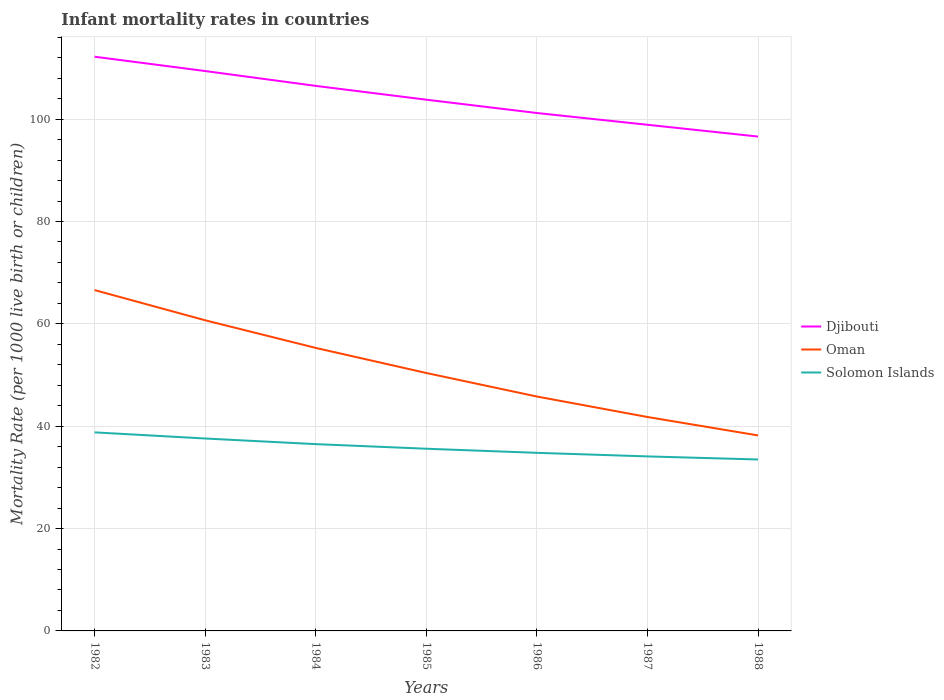How many different coloured lines are there?
Give a very brief answer. 3. Does the line corresponding to Solomon Islands intersect with the line corresponding to Djibouti?
Your response must be concise. No. Across all years, what is the maximum infant mortality rate in Djibouti?
Your answer should be very brief. 96.6. What is the total infant mortality rate in Oman in the graph?
Your response must be concise. 4.9. What is the difference between the highest and the second highest infant mortality rate in Djibouti?
Provide a short and direct response. 15.6. What is the difference between the highest and the lowest infant mortality rate in Solomon Islands?
Make the answer very short. 3. Is the infant mortality rate in Djibouti strictly greater than the infant mortality rate in Solomon Islands over the years?
Make the answer very short. No. How many years are there in the graph?
Make the answer very short. 7. What is the difference between two consecutive major ticks on the Y-axis?
Provide a succinct answer. 20. Does the graph contain grids?
Offer a terse response. Yes. How many legend labels are there?
Offer a very short reply. 3. How are the legend labels stacked?
Provide a short and direct response. Vertical. What is the title of the graph?
Provide a short and direct response. Infant mortality rates in countries. What is the label or title of the Y-axis?
Your answer should be very brief. Mortality Rate (per 1000 live birth or children). What is the Mortality Rate (per 1000 live birth or children) in Djibouti in 1982?
Make the answer very short. 112.2. What is the Mortality Rate (per 1000 live birth or children) in Oman in 1982?
Offer a terse response. 66.6. What is the Mortality Rate (per 1000 live birth or children) of Solomon Islands in 1982?
Give a very brief answer. 38.8. What is the Mortality Rate (per 1000 live birth or children) in Djibouti in 1983?
Offer a terse response. 109.4. What is the Mortality Rate (per 1000 live birth or children) in Oman in 1983?
Ensure brevity in your answer.  60.7. What is the Mortality Rate (per 1000 live birth or children) of Solomon Islands in 1983?
Make the answer very short. 37.6. What is the Mortality Rate (per 1000 live birth or children) of Djibouti in 1984?
Provide a short and direct response. 106.5. What is the Mortality Rate (per 1000 live birth or children) of Oman in 1984?
Offer a very short reply. 55.3. What is the Mortality Rate (per 1000 live birth or children) in Solomon Islands in 1984?
Offer a terse response. 36.5. What is the Mortality Rate (per 1000 live birth or children) of Djibouti in 1985?
Your answer should be very brief. 103.8. What is the Mortality Rate (per 1000 live birth or children) in Oman in 1985?
Provide a succinct answer. 50.4. What is the Mortality Rate (per 1000 live birth or children) in Solomon Islands in 1985?
Offer a very short reply. 35.6. What is the Mortality Rate (per 1000 live birth or children) of Djibouti in 1986?
Offer a very short reply. 101.2. What is the Mortality Rate (per 1000 live birth or children) in Oman in 1986?
Your answer should be compact. 45.8. What is the Mortality Rate (per 1000 live birth or children) of Solomon Islands in 1986?
Your answer should be compact. 34.8. What is the Mortality Rate (per 1000 live birth or children) of Djibouti in 1987?
Offer a terse response. 98.9. What is the Mortality Rate (per 1000 live birth or children) of Oman in 1987?
Keep it short and to the point. 41.8. What is the Mortality Rate (per 1000 live birth or children) in Solomon Islands in 1987?
Keep it short and to the point. 34.1. What is the Mortality Rate (per 1000 live birth or children) of Djibouti in 1988?
Your response must be concise. 96.6. What is the Mortality Rate (per 1000 live birth or children) in Oman in 1988?
Your response must be concise. 38.2. What is the Mortality Rate (per 1000 live birth or children) in Solomon Islands in 1988?
Give a very brief answer. 33.5. Across all years, what is the maximum Mortality Rate (per 1000 live birth or children) of Djibouti?
Make the answer very short. 112.2. Across all years, what is the maximum Mortality Rate (per 1000 live birth or children) of Oman?
Offer a terse response. 66.6. Across all years, what is the maximum Mortality Rate (per 1000 live birth or children) in Solomon Islands?
Offer a terse response. 38.8. Across all years, what is the minimum Mortality Rate (per 1000 live birth or children) in Djibouti?
Your answer should be compact. 96.6. Across all years, what is the minimum Mortality Rate (per 1000 live birth or children) of Oman?
Your answer should be compact. 38.2. Across all years, what is the minimum Mortality Rate (per 1000 live birth or children) of Solomon Islands?
Make the answer very short. 33.5. What is the total Mortality Rate (per 1000 live birth or children) in Djibouti in the graph?
Provide a short and direct response. 728.6. What is the total Mortality Rate (per 1000 live birth or children) of Oman in the graph?
Your answer should be very brief. 358.8. What is the total Mortality Rate (per 1000 live birth or children) of Solomon Islands in the graph?
Give a very brief answer. 250.9. What is the difference between the Mortality Rate (per 1000 live birth or children) in Djibouti in 1982 and that in 1983?
Your answer should be compact. 2.8. What is the difference between the Mortality Rate (per 1000 live birth or children) of Oman in 1982 and that in 1983?
Give a very brief answer. 5.9. What is the difference between the Mortality Rate (per 1000 live birth or children) in Djibouti in 1982 and that in 1985?
Your response must be concise. 8.4. What is the difference between the Mortality Rate (per 1000 live birth or children) of Oman in 1982 and that in 1985?
Offer a terse response. 16.2. What is the difference between the Mortality Rate (per 1000 live birth or children) of Oman in 1982 and that in 1986?
Make the answer very short. 20.8. What is the difference between the Mortality Rate (per 1000 live birth or children) in Solomon Islands in 1982 and that in 1986?
Offer a very short reply. 4. What is the difference between the Mortality Rate (per 1000 live birth or children) in Oman in 1982 and that in 1987?
Keep it short and to the point. 24.8. What is the difference between the Mortality Rate (per 1000 live birth or children) of Djibouti in 1982 and that in 1988?
Ensure brevity in your answer.  15.6. What is the difference between the Mortality Rate (per 1000 live birth or children) in Oman in 1982 and that in 1988?
Ensure brevity in your answer.  28.4. What is the difference between the Mortality Rate (per 1000 live birth or children) of Oman in 1983 and that in 1984?
Your answer should be very brief. 5.4. What is the difference between the Mortality Rate (per 1000 live birth or children) of Solomon Islands in 1983 and that in 1984?
Offer a very short reply. 1.1. What is the difference between the Mortality Rate (per 1000 live birth or children) of Solomon Islands in 1983 and that in 1985?
Make the answer very short. 2. What is the difference between the Mortality Rate (per 1000 live birth or children) of Oman in 1983 and that in 1987?
Provide a short and direct response. 18.9. What is the difference between the Mortality Rate (per 1000 live birth or children) of Djibouti in 1983 and that in 1988?
Ensure brevity in your answer.  12.8. What is the difference between the Mortality Rate (per 1000 live birth or children) of Solomon Islands in 1983 and that in 1988?
Your answer should be compact. 4.1. What is the difference between the Mortality Rate (per 1000 live birth or children) in Oman in 1984 and that in 1985?
Give a very brief answer. 4.9. What is the difference between the Mortality Rate (per 1000 live birth or children) of Solomon Islands in 1984 and that in 1985?
Keep it short and to the point. 0.9. What is the difference between the Mortality Rate (per 1000 live birth or children) of Oman in 1984 and that in 1987?
Offer a very short reply. 13.5. What is the difference between the Mortality Rate (per 1000 live birth or children) in Djibouti in 1985 and that in 1986?
Offer a very short reply. 2.6. What is the difference between the Mortality Rate (per 1000 live birth or children) of Oman in 1985 and that in 1986?
Your answer should be compact. 4.6. What is the difference between the Mortality Rate (per 1000 live birth or children) of Djibouti in 1985 and that in 1987?
Provide a succinct answer. 4.9. What is the difference between the Mortality Rate (per 1000 live birth or children) of Djibouti in 1985 and that in 1988?
Give a very brief answer. 7.2. What is the difference between the Mortality Rate (per 1000 live birth or children) of Oman in 1986 and that in 1987?
Provide a short and direct response. 4. What is the difference between the Mortality Rate (per 1000 live birth or children) in Djibouti in 1986 and that in 1988?
Your answer should be very brief. 4.6. What is the difference between the Mortality Rate (per 1000 live birth or children) in Djibouti in 1987 and that in 1988?
Keep it short and to the point. 2.3. What is the difference between the Mortality Rate (per 1000 live birth or children) in Oman in 1987 and that in 1988?
Make the answer very short. 3.6. What is the difference between the Mortality Rate (per 1000 live birth or children) of Solomon Islands in 1987 and that in 1988?
Your answer should be very brief. 0.6. What is the difference between the Mortality Rate (per 1000 live birth or children) in Djibouti in 1982 and the Mortality Rate (per 1000 live birth or children) in Oman in 1983?
Provide a short and direct response. 51.5. What is the difference between the Mortality Rate (per 1000 live birth or children) of Djibouti in 1982 and the Mortality Rate (per 1000 live birth or children) of Solomon Islands in 1983?
Your response must be concise. 74.6. What is the difference between the Mortality Rate (per 1000 live birth or children) of Djibouti in 1982 and the Mortality Rate (per 1000 live birth or children) of Oman in 1984?
Your answer should be compact. 56.9. What is the difference between the Mortality Rate (per 1000 live birth or children) in Djibouti in 1982 and the Mortality Rate (per 1000 live birth or children) in Solomon Islands in 1984?
Offer a terse response. 75.7. What is the difference between the Mortality Rate (per 1000 live birth or children) of Oman in 1982 and the Mortality Rate (per 1000 live birth or children) of Solomon Islands in 1984?
Ensure brevity in your answer.  30.1. What is the difference between the Mortality Rate (per 1000 live birth or children) of Djibouti in 1982 and the Mortality Rate (per 1000 live birth or children) of Oman in 1985?
Make the answer very short. 61.8. What is the difference between the Mortality Rate (per 1000 live birth or children) of Djibouti in 1982 and the Mortality Rate (per 1000 live birth or children) of Solomon Islands in 1985?
Provide a succinct answer. 76.6. What is the difference between the Mortality Rate (per 1000 live birth or children) of Djibouti in 1982 and the Mortality Rate (per 1000 live birth or children) of Oman in 1986?
Make the answer very short. 66.4. What is the difference between the Mortality Rate (per 1000 live birth or children) of Djibouti in 1982 and the Mortality Rate (per 1000 live birth or children) of Solomon Islands in 1986?
Keep it short and to the point. 77.4. What is the difference between the Mortality Rate (per 1000 live birth or children) in Oman in 1982 and the Mortality Rate (per 1000 live birth or children) in Solomon Islands in 1986?
Keep it short and to the point. 31.8. What is the difference between the Mortality Rate (per 1000 live birth or children) of Djibouti in 1982 and the Mortality Rate (per 1000 live birth or children) of Oman in 1987?
Provide a succinct answer. 70.4. What is the difference between the Mortality Rate (per 1000 live birth or children) in Djibouti in 1982 and the Mortality Rate (per 1000 live birth or children) in Solomon Islands in 1987?
Provide a succinct answer. 78.1. What is the difference between the Mortality Rate (per 1000 live birth or children) in Oman in 1982 and the Mortality Rate (per 1000 live birth or children) in Solomon Islands in 1987?
Ensure brevity in your answer.  32.5. What is the difference between the Mortality Rate (per 1000 live birth or children) of Djibouti in 1982 and the Mortality Rate (per 1000 live birth or children) of Solomon Islands in 1988?
Give a very brief answer. 78.7. What is the difference between the Mortality Rate (per 1000 live birth or children) in Oman in 1982 and the Mortality Rate (per 1000 live birth or children) in Solomon Islands in 1988?
Offer a terse response. 33.1. What is the difference between the Mortality Rate (per 1000 live birth or children) in Djibouti in 1983 and the Mortality Rate (per 1000 live birth or children) in Oman in 1984?
Your answer should be very brief. 54.1. What is the difference between the Mortality Rate (per 1000 live birth or children) of Djibouti in 1983 and the Mortality Rate (per 1000 live birth or children) of Solomon Islands in 1984?
Keep it short and to the point. 72.9. What is the difference between the Mortality Rate (per 1000 live birth or children) in Oman in 1983 and the Mortality Rate (per 1000 live birth or children) in Solomon Islands in 1984?
Make the answer very short. 24.2. What is the difference between the Mortality Rate (per 1000 live birth or children) of Djibouti in 1983 and the Mortality Rate (per 1000 live birth or children) of Solomon Islands in 1985?
Provide a short and direct response. 73.8. What is the difference between the Mortality Rate (per 1000 live birth or children) in Oman in 1983 and the Mortality Rate (per 1000 live birth or children) in Solomon Islands in 1985?
Provide a short and direct response. 25.1. What is the difference between the Mortality Rate (per 1000 live birth or children) of Djibouti in 1983 and the Mortality Rate (per 1000 live birth or children) of Oman in 1986?
Provide a short and direct response. 63.6. What is the difference between the Mortality Rate (per 1000 live birth or children) in Djibouti in 1983 and the Mortality Rate (per 1000 live birth or children) in Solomon Islands in 1986?
Your answer should be very brief. 74.6. What is the difference between the Mortality Rate (per 1000 live birth or children) of Oman in 1983 and the Mortality Rate (per 1000 live birth or children) of Solomon Islands in 1986?
Make the answer very short. 25.9. What is the difference between the Mortality Rate (per 1000 live birth or children) of Djibouti in 1983 and the Mortality Rate (per 1000 live birth or children) of Oman in 1987?
Your answer should be compact. 67.6. What is the difference between the Mortality Rate (per 1000 live birth or children) of Djibouti in 1983 and the Mortality Rate (per 1000 live birth or children) of Solomon Islands in 1987?
Provide a short and direct response. 75.3. What is the difference between the Mortality Rate (per 1000 live birth or children) of Oman in 1983 and the Mortality Rate (per 1000 live birth or children) of Solomon Islands in 1987?
Keep it short and to the point. 26.6. What is the difference between the Mortality Rate (per 1000 live birth or children) in Djibouti in 1983 and the Mortality Rate (per 1000 live birth or children) in Oman in 1988?
Your answer should be very brief. 71.2. What is the difference between the Mortality Rate (per 1000 live birth or children) of Djibouti in 1983 and the Mortality Rate (per 1000 live birth or children) of Solomon Islands in 1988?
Your answer should be compact. 75.9. What is the difference between the Mortality Rate (per 1000 live birth or children) in Oman in 1983 and the Mortality Rate (per 1000 live birth or children) in Solomon Islands in 1988?
Give a very brief answer. 27.2. What is the difference between the Mortality Rate (per 1000 live birth or children) of Djibouti in 1984 and the Mortality Rate (per 1000 live birth or children) of Oman in 1985?
Ensure brevity in your answer.  56.1. What is the difference between the Mortality Rate (per 1000 live birth or children) of Djibouti in 1984 and the Mortality Rate (per 1000 live birth or children) of Solomon Islands in 1985?
Ensure brevity in your answer.  70.9. What is the difference between the Mortality Rate (per 1000 live birth or children) of Oman in 1984 and the Mortality Rate (per 1000 live birth or children) of Solomon Islands in 1985?
Your answer should be very brief. 19.7. What is the difference between the Mortality Rate (per 1000 live birth or children) of Djibouti in 1984 and the Mortality Rate (per 1000 live birth or children) of Oman in 1986?
Make the answer very short. 60.7. What is the difference between the Mortality Rate (per 1000 live birth or children) of Djibouti in 1984 and the Mortality Rate (per 1000 live birth or children) of Solomon Islands in 1986?
Ensure brevity in your answer.  71.7. What is the difference between the Mortality Rate (per 1000 live birth or children) of Oman in 1984 and the Mortality Rate (per 1000 live birth or children) of Solomon Islands in 1986?
Ensure brevity in your answer.  20.5. What is the difference between the Mortality Rate (per 1000 live birth or children) in Djibouti in 1984 and the Mortality Rate (per 1000 live birth or children) in Oman in 1987?
Provide a short and direct response. 64.7. What is the difference between the Mortality Rate (per 1000 live birth or children) of Djibouti in 1984 and the Mortality Rate (per 1000 live birth or children) of Solomon Islands in 1987?
Give a very brief answer. 72.4. What is the difference between the Mortality Rate (per 1000 live birth or children) of Oman in 1984 and the Mortality Rate (per 1000 live birth or children) of Solomon Islands in 1987?
Your response must be concise. 21.2. What is the difference between the Mortality Rate (per 1000 live birth or children) of Djibouti in 1984 and the Mortality Rate (per 1000 live birth or children) of Oman in 1988?
Your response must be concise. 68.3. What is the difference between the Mortality Rate (per 1000 live birth or children) of Djibouti in 1984 and the Mortality Rate (per 1000 live birth or children) of Solomon Islands in 1988?
Your answer should be compact. 73. What is the difference between the Mortality Rate (per 1000 live birth or children) in Oman in 1984 and the Mortality Rate (per 1000 live birth or children) in Solomon Islands in 1988?
Make the answer very short. 21.8. What is the difference between the Mortality Rate (per 1000 live birth or children) in Djibouti in 1985 and the Mortality Rate (per 1000 live birth or children) in Solomon Islands in 1986?
Your answer should be compact. 69. What is the difference between the Mortality Rate (per 1000 live birth or children) of Oman in 1985 and the Mortality Rate (per 1000 live birth or children) of Solomon Islands in 1986?
Offer a terse response. 15.6. What is the difference between the Mortality Rate (per 1000 live birth or children) in Djibouti in 1985 and the Mortality Rate (per 1000 live birth or children) in Oman in 1987?
Your answer should be compact. 62. What is the difference between the Mortality Rate (per 1000 live birth or children) in Djibouti in 1985 and the Mortality Rate (per 1000 live birth or children) in Solomon Islands in 1987?
Your answer should be compact. 69.7. What is the difference between the Mortality Rate (per 1000 live birth or children) in Djibouti in 1985 and the Mortality Rate (per 1000 live birth or children) in Oman in 1988?
Your answer should be compact. 65.6. What is the difference between the Mortality Rate (per 1000 live birth or children) in Djibouti in 1985 and the Mortality Rate (per 1000 live birth or children) in Solomon Islands in 1988?
Offer a terse response. 70.3. What is the difference between the Mortality Rate (per 1000 live birth or children) of Oman in 1985 and the Mortality Rate (per 1000 live birth or children) of Solomon Islands in 1988?
Provide a short and direct response. 16.9. What is the difference between the Mortality Rate (per 1000 live birth or children) in Djibouti in 1986 and the Mortality Rate (per 1000 live birth or children) in Oman in 1987?
Provide a succinct answer. 59.4. What is the difference between the Mortality Rate (per 1000 live birth or children) of Djibouti in 1986 and the Mortality Rate (per 1000 live birth or children) of Solomon Islands in 1987?
Offer a very short reply. 67.1. What is the difference between the Mortality Rate (per 1000 live birth or children) in Djibouti in 1986 and the Mortality Rate (per 1000 live birth or children) in Oman in 1988?
Provide a succinct answer. 63. What is the difference between the Mortality Rate (per 1000 live birth or children) of Djibouti in 1986 and the Mortality Rate (per 1000 live birth or children) of Solomon Islands in 1988?
Keep it short and to the point. 67.7. What is the difference between the Mortality Rate (per 1000 live birth or children) in Djibouti in 1987 and the Mortality Rate (per 1000 live birth or children) in Oman in 1988?
Your response must be concise. 60.7. What is the difference between the Mortality Rate (per 1000 live birth or children) of Djibouti in 1987 and the Mortality Rate (per 1000 live birth or children) of Solomon Islands in 1988?
Provide a succinct answer. 65.4. What is the average Mortality Rate (per 1000 live birth or children) in Djibouti per year?
Provide a short and direct response. 104.09. What is the average Mortality Rate (per 1000 live birth or children) in Oman per year?
Ensure brevity in your answer.  51.26. What is the average Mortality Rate (per 1000 live birth or children) in Solomon Islands per year?
Provide a short and direct response. 35.84. In the year 1982, what is the difference between the Mortality Rate (per 1000 live birth or children) of Djibouti and Mortality Rate (per 1000 live birth or children) of Oman?
Your answer should be compact. 45.6. In the year 1982, what is the difference between the Mortality Rate (per 1000 live birth or children) in Djibouti and Mortality Rate (per 1000 live birth or children) in Solomon Islands?
Give a very brief answer. 73.4. In the year 1982, what is the difference between the Mortality Rate (per 1000 live birth or children) of Oman and Mortality Rate (per 1000 live birth or children) of Solomon Islands?
Your response must be concise. 27.8. In the year 1983, what is the difference between the Mortality Rate (per 1000 live birth or children) of Djibouti and Mortality Rate (per 1000 live birth or children) of Oman?
Provide a succinct answer. 48.7. In the year 1983, what is the difference between the Mortality Rate (per 1000 live birth or children) of Djibouti and Mortality Rate (per 1000 live birth or children) of Solomon Islands?
Provide a succinct answer. 71.8. In the year 1983, what is the difference between the Mortality Rate (per 1000 live birth or children) in Oman and Mortality Rate (per 1000 live birth or children) in Solomon Islands?
Give a very brief answer. 23.1. In the year 1984, what is the difference between the Mortality Rate (per 1000 live birth or children) of Djibouti and Mortality Rate (per 1000 live birth or children) of Oman?
Your answer should be compact. 51.2. In the year 1984, what is the difference between the Mortality Rate (per 1000 live birth or children) in Djibouti and Mortality Rate (per 1000 live birth or children) in Solomon Islands?
Provide a succinct answer. 70. In the year 1984, what is the difference between the Mortality Rate (per 1000 live birth or children) of Oman and Mortality Rate (per 1000 live birth or children) of Solomon Islands?
Provide a succinct answer. 18.8. In the year 1985, what is the difference between the Mortality Rate (per 1000 live birth or children) of Djibouti and Mortality Rate (per 1000 live birth or children) of Oman?
Your answer should be very brief. 53.4. In the year 1985, what is the difference between the Mortality Rate (per 1000 live birth or children) of Djibouti and Mortality Rate (per 1000 live birth or children) of Solomon Islands?
Keep it short and to the point. 68.2. In the year 1985, what is the difference between the Mortality Rate (per 1000 live birth or children) in Oman and Mortality Rate (per 1000 live birth or children) in Solomon Islands?
Your response must be concise. 14.8. In the year 1986, what is the difference between the Mortality Rate (per 1000 live birth or children) of Djibouti and Mortality Rate (per 1000 live birth or children) of Oman?
Provide a succinct answer. 55.4. In the year 1986, what is the difference between the Mortality Rate (per 1000 live birth or children) in Djibouti and Mortality Rate (per 1000 live birth or children) in Solomon Islands?
Give a very brief answer. 66.4. In the year 1987, what is the difference between the Mortality Rate (per 1000 live birth or children) in Djibouti and Mortality Rate (per 1000 live birth or children) in Oman?
Keep it short and to the point. 57.1. In the year 1987, what is the difference between the Mortality Rate (per 1000 live birth or children) of Djibouti and Mortality Rate (per 1000 live birth or children) of Solomon Islands?
Make the answer very short. 64.8. In the year 1988, what is the difference between the Mortality Rate (per 1000 live birth or children) of Djibouti and Mortality Rate (per 1000 live birth or children) of Oman?
Keep it short and to the point. 58.4. In the year 1988, what is the difference between the Mortality Rate (per 1000 live birth or children) of Djibouti and Mortality Rate (per 1000 live birth or children) of Solomon Islands?
Provide a succinct answer. 63.1. In the year 1988, what is the difference between the Mortality Rate (per 1000 live birth or children) of Oman and Mortality Rate (per 1000 live birth or children) of Solomon Islands?
Your answer should be compact. 4.7. What is the ratio of the Mortality Rate (per 1000 live birth or children) in Djibouti in 1982 to that in 1983?
Give a very brief answer. 1.03. What is the ratio of the Mortality Rate (per 1000 live birth or children) of Oman in 1982 to that in 1983?
Make the answer very short. 1.1. What is the ratio of the Mortality Rate (per 1000 live birth or children) of Solomon Islands in 1982 to that in 1983?
Your response must be concise. 1.03. What is the ratio of the Mortality Rate (per 1000 live birth or children) in Djibouti in 1982 to that in 1984?
Provide a short and direct response. 1.05. What is the ratio of the Mortality Rate (per 1000 live birth or children) of Oman in 1982 to that in 1984?
Keep it short and to the point. 1.2. What is the ratio of the Mortality Rate (per 1000 live birth or children) of Solomon Islands in 1982 to that in 1984?
Your answer should be very brief. 1.06. What is the ratio of the Mortality Rate (per 1000 live birth or children) in Djibouti in 1982 to that in 1985?
Your answer should be compact. 1.08. What is the ratio of the Mortality Rate (per 1000 live birth or children) of Oman in 1982 to that in 1985?
Offer a terse response. 1.32. What is the ratio of the Mortality Rate (per 1000 live birth or children) in Solomon Islands in 1982 to that in 1985?
Your answer should be compact. 1.09. What is the ratio of the Mortality Rate (per 1000 live birth or children) in Djibouti in 1982 to that in 1986?
Make the answer very short. 1.11. What is the ratio of the Mortality Rate (per 1000 live birth or children) in Oman in 1982 to that in 1986?
Make the answer very short. 1.45. What is the ratio of the Mortality Rate (per 1000 live birth or children) of Solomon Islands in 1982 to that in 1986?
Ensure brevity in your answer.  1.11. What is the ratio of the Mortality Rate (per 1000 live birth or children) in Djibouti in 1982 to that in 1987?
Provide a short and direct response. 1.13. What is the ratio of the Mortality Rate (per 1000 live birth or children) in Oman in 1982 to that in 1987?
Ensure brevity in your answer.  1.59. What is the ratio of the Mortality Rate (per 1000 live birth or children) of Solomon Islands in 1982 to that in 1987?
Make the answer very short. 1.14. What is the ratio of the Mortality Rate (per 1000 live birth or children) in Djibouti in 1982 to that in 1988?
Give a very brief answer. 1.16. What is the ratio of the Mortality Rate (per 1000 live birth or children) in Oman in 1982 to that in 1988?
Your response must be concise. 1.74. What is the ratio of the Mortality Rate (per 1000 live birth or children) of Solomon Islands in 1982 to that in 1988?
Give a very brief answer. 1.16. What is the ratio of the Mortality Rate (per 1000 live birth or children) of Djibouti in 1983 to that in 1984?
Your answer should be very brief. 1.03. What is the ratio of the Mortality Rate (per 1000 live birth or children) of Oman in 1983 to that in 1984?
Provide a short and direct response. 1.1. What is the ratio of the Mortality Rate (per 1000 live birth or children) of Solomon Islands in 1983 to that in 1984?
Provide a short and direct response. 1.03. What is the ratio of the Mortality Rate (per 1000 live birth or children) of Djibouti in 1983 to that in 1985?
Give a very brief answer. 1.05. What is the ratio of the Mortality Rate (per 1000 live birth or children) in Oman in 1983 to that in 1985?
Keep it short and to the point. 1.2. What is the ratio of the Mortality Rate (per 1000 live birth or children) in Solomon Islands in 1983 to that in 1985?
Keep it short and to the point. 1.06. What is the ratio of the Mortality Rate (per 1000 live birth or children) of Djibouti in 1983 to that in 1986?
Give a very brief answer. 1.08. What is the ratio of the Mortality Rate (per 1000 live birth or children) in Oman in 1983 to that in 1986?
Your answer should be very brief. 1.33. What is the ratio of the Mortality Rate (per 1000 live birth or children) in Solomon Islands in 1983 to that in 1986?
Offer a very short reply. 1.08. What is the ratio of the Mortality Rate (per 1000 live birth or children) in Djibouti in 1983 to that in 1987?
Your answer should be very brief. 1.11. What is the ratio of the Mortality Rate (per 1000 live birth or children) of Oman in 1983 to that in 1987?
Offer a terse response. 1.45. What is the ratio of the Mortality Rate (per 1000 live birth or children) in Solomon Islands in 1983 to that in 1987?
Offer a terse response. 1.1. What is the ratio of the Mortality Rate (per 1000 live birth or children) of Djibouti in 1983 to that in 1988?
Give a very brief answer. 1.13. What is the ratio of the Mortality Rate (per 1000 live birth or children) of Oman in 1983 to that in 1988?
Your response must be concise. 1.59. What is the ratio of the Mortality Rate (per 1000 live birth or children) in Solomon Islands in 1983 to that in 1988?
Offer a very short reply. 1.12. What is the ratio of the Mortality Rate (per 1000 live birth or children) in Djibouti in 1984 to that in 1985?
Offer a terse response. 1.03. What is the ratio of the Mortality Rate (per 1000 live birth or children) of Oman in 1984 to that in 1985?
Your answer should be compact. 1.1. What is the ratio of the Mortality Rate (per 1000 live birth or children) of Solomon Islands in 1984 to that in 1985?
Ensure brevity in your answer.  1.03. What is the ratio of the Mortality Rate (per 1000 live birth or children) in Djibouti in 1984 to that in 1986?
Make the answer very short. 1.05. What is the ratio of the Mortality Rate (per 1000 live birth or children) in Oman in 1984 to that in 1986?
Your answer should be compact. 1.21. What is the ratio of the Mortality Rate (per 1000 live birth or children) in Solomon Islands in 1984 to that in 1986?
Your response must be concise. 1.05. What is the ratio of the Mortality Rate (per 1000 live birth or children) in Djibouti in 1984 to that in 1987?
Your answer should be very brief. 1.08. What is the ratio of the Mortality Rate (per 1000 live birth or children) of Oman in 1984 to that in 1987?
Give a very brief answer. 1.32. What is the ratio of the Mortality Rate (per 1000 live birth or children) of Solomon Islands in 1984 to that in 1987?
Give a very brief answer. 1.07. What is the ratio of the Mortality Rate (per 1000 live birth or children) of Djibouti in 1984 to that in 1988?
Ensure brevity in your answer.  1.1. What is the ratio of the Mortality Rate (per 1000 live birth or children) in Oman in 1984 to that in 1988?
Provide a short and direct response. 1.45. What is the ratio of the Mortality Rate (per 1000 live birth or children) in Solomon Islands in 1984 to that in 1988?
Make the answer very short. 1.09. What is the ratio of the Mortality Rate (per 1000 live birth or children) in Djibouti in 1985 to that in 1986?
Make the answer very short. 1.03. What is the ratio of the Mortality Rate (per 1000 live birth or children) in Oman in 1985 to that in 1986?
Your response must be concise. 1.1. What is the ratio of the Mortality Rate (per 1000 live birth or children) of Solomon Islands in 1985 to that in 1986?
Make the answer very short. 1.02. What is the ratio of the Mortality Rate (per 1000 live birth or children) of Djibouti in 1985 to that in 1987?
Provide a succinct answer. 1.05. What is the ratio of the Mortality Rate (per 1000 live birth or children) of Oman in 1985 to that in 1987?
Ensure brevity in your answer.  1.21. What is the ratio of the Mortality Rate (per 1000 live birth or children) of Solomon Islands in 1985 to that in 1987?
Give a very brief answer. 1.04. What is the ratio of the Mortality Rate (per 1000 live birth or children) of Djibouti in 1985 to that in 1988?
Offer a very short reply. 1.07. What is the ratio of the Mortality Rate (per 1000 live birth or children) in Oman in 1985 to that in 1988?
Offer a very short reply. 1.32. What is the ratio of the Mortality Rate (per 1000 live birth or children) in Solomon Islands in 1985 to that in 1988?
Keep it short and to the point. 1.06. What is the ratio of the Mortality Rate (per 1000 live birth or children) in Djibouti in 1986 to that in 1987?
Your answer should be very brief. 1.02. What is the ratio of the Mortality Rate (per 1000 live birth or children) in Oman in 1986 to that in 1987?
Your answer should be compact. 1.1. What is the ratio of the Mortality Rate (per 1000 live birth or children) in Solomon Islands in 1986 to that in 1987?
Your response must be concise. 1.02. What is the ratio of the Mortality Rate (per 1000 live birth or children) of Djibouti in 1986 to that in 1988?
Offer a very short reply. 1.05. What is the ratio of the Mortality Rate (per 1000 live birth or children) of Oman in 1986 to that in 1988?
Offer a very short reply. 1.2. What is the ratio of the Mortality Rate (per 1000 live birth or children) in Solomon Islands in 1986 to that in 1988?
Your answer should be very brief. 1.04. What is the ratio of the Mortality Rate (per 1000 live birth or children) in Djibouti in 1987 to that in 1988?
Make the answer very short. 1.02. What is the ratio of the Mortality Rate (per 1000 live birth or children) in Oman in 1987 to that in 1988?
Offer a terse response. 1.09. What is the ratio of the Mortality Rate (per 1000 live birth or children) of Solomon Islands in 1987 to that in 1988?
Your response must be concise. 1.02. What is the difference between the highest and the lowest Mortality Rate (per 1000 live birth or children) in Oman?
Offer a terse response. 28.4. 